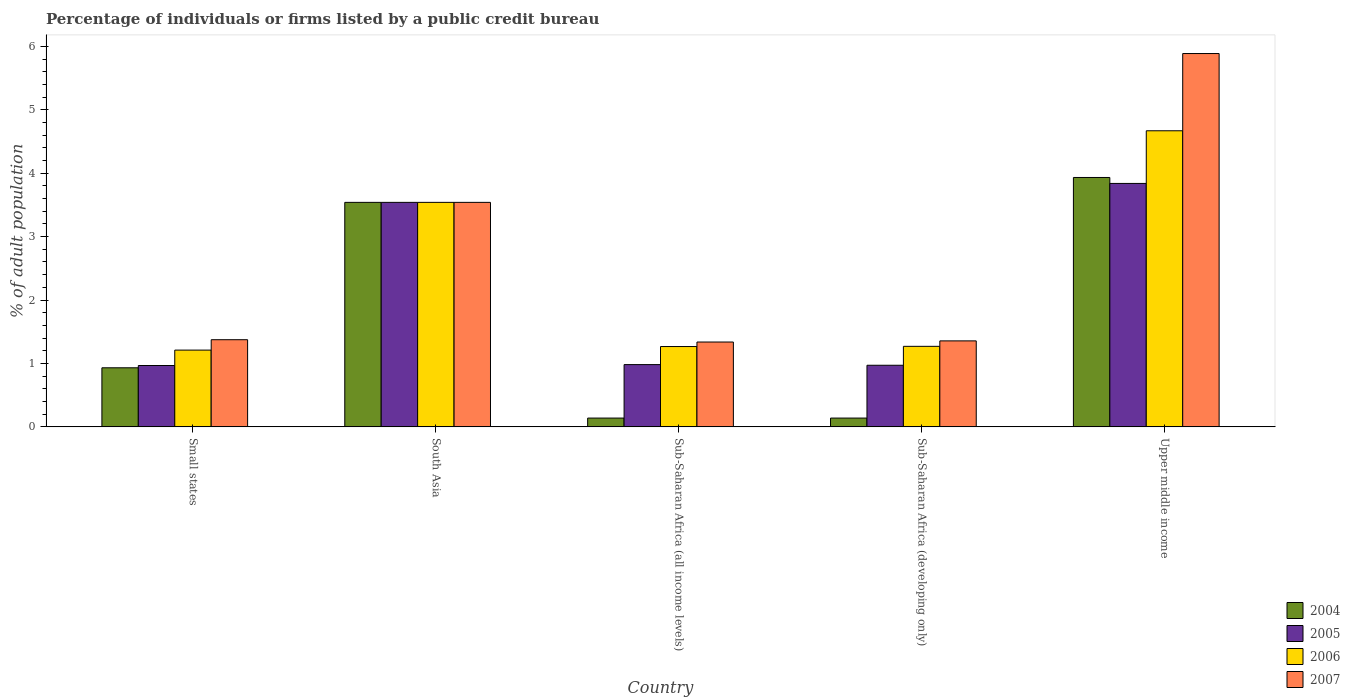How many different coloured bars are there?
Offer a very short reply. 4. How many groups of bars are there?
Provide a short and direct response. 5. Are the number of bars per tick equal to the number of legend labels?
Keep it short and to the point. Yes. Are the number of bars on each tick of the X-axis equal?
Provide a succinct answer. Yes. How many bars are there on the 3rd tick from the left?
Your answer should be compact. 4. How many bars are there on the 4th tick from the right?
Give a very brief answer. 4. In how many cases, is the number of bars for a given country not equal to the number of legend labels?
Your answer should be compact. 0. What is the percentage of population listed by a public credit bureau in 2004 in South Asia?
Offer a very short reply. 3.54. Across all countries, what is the maximum percentage of population listed by a public credit bureau in 2004?
Your answer should be compact. 3.93. Across all countries, what is the minimum percentage of population listed by a public credit bureau in 2004?
Your answer should be compact. 0.14. In which country was the percentage of population listed by a public credit bureau in 2005 maximum?
Give a very brief answer. Upper middle income. In which country was the percentage of population listed by a public credit bureau in 2006 minimum?
Offer a terse response. Small states. What is the total percentage of population listed by a public credit bureau in 2007 in the graph?
Your answer should be very brief. 13.49. What is the difference between the percentage of population listed by a public credit bureau in 2007 in Sub-Saharan Africa (developing only) and that in Upper middle income?
Make the answer very short. -4.53. What is the difference between the percentage of population listed by a public credit bureau in 2007 in Sub-Saharan Africa (all income levels) and the percentage of population listed by a public credit bureau in 2006 in Small states?
Give a very brief answer. 0.13. What is the average percentage of population listed by a public credit bureau in 2005 per country?
Give a very brief answer. 2.06. What is the ratio of the percentage of population listed by a public credit bureau in 2007 in South Asia to that in Upper middle income?
Your response must be concise. 0.6. Is the percentage of population listed by a public credit bureau in 2007 in Sub-Saharan Africa (all income levels) less than that in Sub-Saharan Africa (developing only)?
Your answer should be compact. Yes. Is the difference between the percentage of population listed by a public credit bureau in 2006 in South Asia and Sub-Saharan Africa (developing only) greater than the difference between the percentage of population listed by a public credit bureau in 2004 in South Asia and Sub-Saharan Africa (developing only)?
Your answer should be very brief. No. What is the difference between the highest and the second highest percentage of population listed by a public credit bureau in 2004?
Your answer should be compact. 2.61. What is the difference between the highest and the lowest percentage of population listed by a public credit bureau in 2006?
Offer a very short reply. 3.46. Is the sum of the percentage of population listed by a public credit bureau in 2006 in Sub-Saharan Africa (developing only) and Upper middle income greater than the maximum percentage of population listed by a public credit bureau in 2005 across all countries?
Provide a succinct answer. Yes. What does the 1st bar from the left in Sub-Saharan Africa (all income levels) represents?
Your answer should be very brief. 2004. Is it the case that in every country, the sum of the percentage of population listed by a public credit bureau in 2005 and percentage of population listed by a public credit bureau in 2004 is greater than the percentage of population listed by a public credit bureau in 2006?
Offer a very short reply. No. Are all the bars in the graph horizontal?
Ensure brevity in your answer.  No. Does the graph contain any zero values?
Keep it short and to the point. No. What is the title of the graph?
Give a very brief answer. Percentage of individuals or firms listed by a public credit bureau. What is the label or title of the X-axis?
Give a very brief answer. Country. What is the label or title of the Y-axis?
Make the answer very short. % of adult population. What is the % of adult population of 2004 in Small states?
Make the answer very short. 0.93. What is the % of adult population of 2005 in Small states?
Offer a terse response. 0.97. What is the % of adult population of 2006 in Small states?
Your answer should be very brief. 1.21. What is the % of adult population of 2007 in Small states?
Provide a short and direct response. 1.37. What is the % of adult population in 2004 in South Asia?
Your response must be concise. 3.54. What is the % of adult population in 2005 in South Asia?
Keep it short and to the point. 3.54. What is the % of adult population of 2006 in South Asia?
Give a very brief answer. 3.54. What is the % of adult population of 2007 in South Asia?
Make the answer very short. 3.54. What is the % of adult population of 2004 in Sub-Saharan Africa (all income levels)?
Your answer should be very brief. 0.14. What is the % of adult population of 2005 in Sub-Saharan Africa (all income levels)?
Make the answer very short. 0.98. What is the % of adult population of 2006 in Sub-Saharan Africa (all income levels)?
Provide a succinct answer. 1.27. What is the % of adult population of 2007 in Sub-Saharan Africa (all income levels)?
Make the answer very short. 1.34. What is the % of adult population of 2004 in Sub-Saharan Africa (developing only)?
Provide a succinct answer. 0.14. What is the % of adult population in 2005 in Sub-Saharan Africa (developing only)?
Offer a very short reply. 0.97. What is the % of adult population in 2006 in Sub-Saharan Africa (developing only)?
Offer a terse response. 1.27. What is the % of adult population of 2007 in Sub-Saharan Africa (developing only)?
Ensure brevity in your answer.  1.36. What is the % of adult population of 2004 in Upper middle income?
Make the answer very short. 3.93. What is the % of adult population of 2005 in Upper middle income?
Give a very brief answer. 3.84. What is the % of adult population of 2006 in Upper middle income?
Offer a very short reply. 4.67. What is the % of adult population of 2007 in Upper middle income?
Offer a very short reply. 5.89. Across all countries, what is the maximum % of adult population in 2004?
Ensure brevity in your answer.  3.93. Across all countries, what is the maximum % of adult population of 2005?
Provide a succinct answer. 3.84. Across all countries, what is the maximum % of adult population of 2006?
Offer a terse response. 4.67. Across all countries, what is the maximum % of adult population in 2007?
Provide a short and direct response. 5.89. Across all countries, what is the minimum % of adult population of 2004?
Give a very brief answer. 0.14. Across all countries, what is the minimum % of adult population of 2005?
Your answer should be compact. 0.97. Across all countries, what is the minimum % of adult population in 2006?
Ensure brevity in your answer.  1.21. Across all countries, what is the minimum % of adult population of 2007?
Make the answer very short. 1.34. What is the total % of adult population of 2004 in the graph?
Offer a terse response. 8.68. What is the total % of adult population in 2005 in the graph?
Your answer should be very brief. 10.3. What is the total % of adult population in 2006 in the graph?
Provide a succinct answer. 11.96. What is the total % of adult population in 2007 in the graph?
Your response must be concise. 13.49. What is the difference between the % of adult population of 2004 in Small states and that in South Asia?
Offer a very short reply. -2.61. What is the difference between the % of adult population of 2005 in Small states and that in South Asia?
Your answer should be very brief. -2.57. What is the difference between the % of adult population of 2006 in Small states and that in South Asia?
Your answer should be very brief. -2.33. What is the difference between the % of adult population in 2007 in Small states and that in South Asia?
Provide a short and direct response. -2.17. What is the difference between the % of adult population in 2004 in Small states and that in Sub-Saharan Africa (all income levels)?
Your response must be concise. 0.79. What is the difference between the % of adult population in 2005 in Small states and that in Sub-Saharan Africa (all income levels)?
Keep it short and to the point. -0.01. What is the difference between the % of adult population of 2006 in Small states and that in Sub-Saharan Africa (all income levels)?
Keep it short and to the point. -0.06. What is the difference between the % of adult population of 2007 in Small states and that in Sub-Saharan Africa (all income levels)?
Make the answer very short. 0.04. What is the difference between the % of adult population of 2004 in Small states and that in Sub-Saharan Africa (developing only)?
Keep it short and to the point. 0.79. What is the difference between the % of adult population in 2005 in Small states and that in Sub-Saharan Africa (developing only)?
Your answer should be compact. -0. What is the difference between the % of adult population of 2006 in Small states and that in Sub-Saharan Africa (developing only)?
Make the answer very short. -0.06. What is the difference between the % of adult population of 2007 in Small states and that in Sub-Saharan Africa (developing only)?
Your answer should be very brief. 0.02. What is the difference between the % of adult population of 2004 in Small states and that in Upper middle income?
Your answer should be compact. -3. What is the difference between the % of adult population in 2005 in Small states and that in Upper middle income?
Provide a short and direct response. -2.87. What is the difference between the % of adult population of 2006 in Small states and that in Upper middle income?
Offer a very short reply. -3.46. What is the difference between the % of adult population of 2007 in Small states and that in Upper middle income?
Provide a succinct answer. -4.51. What is the difference between the % of adult population in 2004 in South Asia and that in Sub-Saharan Africa (all income levels)?
Offer a terse response. 3.4. What is the difference between the % of adult population of 2005 in South Asia and that in Sub-Saharan Africa (all income levels)?
Your answer should be very brief. 2.56. What is the difference between the % of adult population of 2006 in South Asia and that in Sub-Saharan Africa (all income levels)?
Offer a very short reply. 2.27. What is the difference between the % of adult population in 2007 in South Asia and that in Sub-Saharan Africa (all income levels)?
Give a very brief answer. 2.2. What is the difference between the % of adult population in 2004 in South Asia and that in Sub-Saharan Africa (developing only)?
Offer a terse response. 3.4. What is the difference between the % of adult population of 2005 in South Asia and that in Sub-Saharan Africa (developing only)?
Offer a very short reply. 2.57. What is the difference between the % of adult population of 2006 in South Asia and that in Sub-Saharan Africa (developing only)?
Offer a very short reply. 2.27. What is the difference between the % of adult population in 2007 in South Asia and that in Sub-Saharan Africa (developing only)?
Give a very brief answer. 2.18. What is the difference between the % of adult population in 2004 in South Asia and that in Upper middle income?
Offer a terse response. -0.39. What is the difference between the % of adult population of 2005 in South Asia and that in Upper middle income?
Keep it short and to the point. -0.3. What is the difference between the % of adult population in 2006 in South Asia and that in Upper middle income?
Your response must be concise. -1.13. What is the difference between the % of adult population of 2007 in South Asia and that in Upper middle income?
Ensure brevity in your answer.  -2.35. What is the difference between the % of adult population of 2004 in Sub-Saharan Africa (all income levels) and that in Sub-Saharan Africa (developing only)?
Offer a terse response. 0. What is the difference between the % of adult population in 2005 in Sub-Saharan Africa (all income levels) and that in Sub-Saharan Africa (developing only)?
Provide a succinct answer. 0.01. What is the difference between the % of adult population of 2006 in Sub-Saharan Africa (all income levels) and that in Sub-Saharan Africa (developing only)?
Your answer should be very brief. -0. What is the difference between the % of adult population of 2007 in Sub-Saharan Africa (all income levels) and that in Sub-Saharan Africa (developing only)?
Provide a short and direct response. -0.02. What is the difference between the % of adult population in 2004 in Sub-Saharan Africa (all income levels) and that in Upper middle income?
Offer a terse response. -3.79. What is the difference between the % of adult population in 2005 in Sub-Saharan Africa (all income levels) and that in Upper middle income?
Give a very brief answer. -2.86. What is the difference between the % of adult population of 2006 in Sub-Saharan Africa (all income levels) and that in Upper middle income?
Provide a succinct answer. -3.4. What is the difference between the % of adult population in 2007 in Sub-Saharan Africa (all income levels) and that in Upper middle income?
Make the answer very short. -4.55. What is the difference between the % of adult population of 2004 in Sub-Saharan Africa (developing only) and that in Upper middle income?
Give a very brief answer. -3.79. What is the difference between the % of adult population of 2005 in Sub-Saharan Africa (developing only) and that in Upper middle income?
Provide a succinct answer. -2.87. What is the difference between the % of adult population in 2006 in Sub-Saharan Africa (developing only) and that in Upper middle income?
Ensure brevity in your answer.  -3.4. What is the difference between the % of adult population of 2007 in Sub-Saharan Africa (developing only) and that in Upper middle income?
Make the answer very short. -4.53. What is the difference between the % of adult population of 2004 in Small states and the % of adult population of 2005 in South Asia?
Keep it short and to the point. -2.61. What is the difference between the % of adult population in 2004 in Small states and the % of adult population in 2006 in South Asia?
Give a very brief answer. -2.61. What is the difference between the % of adult population of 2004 in Small states and the % of adult population of 2007 in South Asia?
Ensure brevity in your answer.  -2.61. What is the difference between the % of adult population of 2005 in Small states and the % of adult population of 2006 in South Asia?
Your answer should be very brief. -2.57. What is the difference between the % of adult population in 2005 in Small states and the % of adult population in 2007 in South Asia?
Provide a short and direct response. -2.57. What is the difference between the % of adult population in 2006 in Small states and the % of adult population in 2007 in South Asia?
Offer a very short reply. -2.33. What is the difference between the % of adult population in 2004 in Small states and the % of adult population in 2005 in Sub-Saharan Africa (all income levels)?
Offer a terse response. -0.05. What is the difference between the % of adult population of 2004 in Small states and the % of adult population of 2006 in Sub-Saharan Africa (all income levels)?
Offer a terse response. -0.34. What is the difference between the % of adult population of 2004 in Small states and the % of adult population of 2007 in Sub-Saharan Africa (all income levels)?
Your response must be concise. -0.41. What is the difference between the % of adult population of 2005 in Small states and the % of adult population of 2006 in Sub-Saharan Africa (all income levels)?
Offer a very short reply. -0.3. What is the difference between the % of adult population of 2005 in Small states and the % of adult population of 2007 in Sub-Saharan Africa (all income levels)?
Offer a very short reply. -0.37. What is the difference between the % of adult population of 2006 in Small states and the % of adult population of 2007 in Sub-Saharan Africa (all income levels)?
Offer a terse response. -0.13. What is the difference between the % of adult population in 2004 in Small states and the % of adult population in 2005 in Sub-Saharan Africa (developing only)?
Offer a very short reply. -0.04. What is the difference between the % of adult population in 2004 in Small states and the % of adult population in 2006 in Sub-Saharan Africa (developing only)?
Make the answer very short. -0.34. What is the difference between the % of adult population in 2004 in Small states and the % of adult population in 2007 in Sub-Saharan Africa (developing only)?
Offer a very short reply. -0.42. What is the difference between the % of adult population in 2005 in Small states and the % of adult population in 2006 in Sub-Saharan Africa (developing only)?
Your answer should be very brief. -0.3. What is the difference between the % of adult population of 2005 in Small states and the % of adult population of 2007 in Sub-Saharan Africa (developing only)?
Offer a terse response. -0.39. What is the difference between the % of adult population of 2006 in Small states and the % of adult population of 2007 in Sub-Saharan Africa (developing only)?
Offer a terse response. -0.15. What is the difference between the % of adult population of 2004 in Small states and the % of adult population of 2005 in Upper middle income?
Give a very brief answer. -2.91. What is the difference between the % of adult population of 2004 in Small states and the % of adult population of 2006 in Upper middle income?
Provide a succinct answer. -3.74. What is the difference between the % of adult population of 2004 in Small states and the % of adult population of 2007 in Upper middle income?
Your answer should be very brief. -4.96. What is the difference between the % of adult population in 2005 in Small states and the % of adult population in 2006 in Upper middle income?
Make the answer very short. -3.7. What is the difference between the % of adult population of 2005 in Small states and the % of adult population of 2007 in Upper middle income?
Offer a terse response. -4.92. What is the difference between the % of adult population in 2006 in Small states and the % of adult population in 2007 in Upper middle income?
Make the answer very short. -4.68. What is the difference between the % of adult population of 2004 in South Asia and the % of adult population of 2005 in Sub-Saharan Africa (all income levels)?
Make the answer very short. 2.56. What is the difference between the % of adult population in 2004 in South Asia and the % of adult population in 2006 in Sub-Saharan Africa (all income levels)?
Provide a short and direct response. 2.27. What is the difference between the % of adult population of 2004 in South Asia and the % of adult population of 2007 in Sub-Saharan Africa (all income levels)?
Give a very brief answer. 2.2. What is the difference between the % of adult population of 2005 in South Asia and the % of adult population of 2006 in Sub-Saharan Africa (all income levels)?
Provide a succinct answer. 2.27. What is the difference between the % of adult population of 2005 in South Asia and the % of adult population of 2007 in Sub-Saharan Africa (all income levels)?
Ensure brevity in your answer.  2.2. What is the difference between the % of adult population in 2006 in South Asia and the % of adult population in 2007 in Sub-Saharan Africa (all income levels)?
Provide a succinct answer. 2.2. What is the difference between the % of adult population of 2004 in South Asia and the % of adult population of 2005 in Sub-Saharan Africa (developing only)?
Your response must be concise. 2.57. What is the difference between the % of adult population of 2004 in South Asia and the % of adult population of 2006 in Sub-Saharan Africa (developing only)?
Give a very brief answer. 2.27. What is the difference between the % of adult population in 2004 in South Asia and the % of adult population in 2007 in Sub-Saharan Africa (developing only)?
Keep it short and to the point. 2.18. What is the difference between the % of adult population in 2005 in South Asia and the % of adult population in 2006 in Sub-Saharan Africa (developing only)?
Offer a very short reply. 2.27. What is the difference between the % of adult population in 2005 in South Asia and the % of adult population in 2007 in Sub-Saharan Africa (developing only)?
Ensure brevity in your answer.  2.18. What is the difference between the % of adult population of 2006 in South Asia and the % of adult population of 2007 in Sub-Saharan Africa (developing only)?
Your answer should be compact. 2.18. What is the difference between the % of adult population in 2004 in South Asia and the % of adult population in 2005 in Upper middle income?
Provide a short and direct response. -0.3. What is the difference between the % of adult population in 2004 in South Asia and the % of adult population in 2006 in Upper middle income?
Keep it short and to the point. -1.13. What is the difference between the % of adult population of 2004 in South Asia and the % of adult population of 2007 in Upper middle income?
Provide a short and direct response. -2.35. What is the difference between the % of adult population in 2005 in South Asia and the % of adult population in 2006 in Upper middle income?
Your answer should be very brief. -1.13. What is the difference between the % of adult population in 2005 in South Asia and the % of adult population in 2007 in Upper middle income?
Your answer should be very brief. -2.35. What is the difference between the % of adult population of 2006 in South Asia and the % of adult population of 2007 in Upper middle income?
Provide a short and direct response. -2.35. What is the difference between the % of adult population in 2004 in Sub-Saharan Africa (all income levels) and the % of adult population in 2005 in Sub-Saharan Africa (developing only)?
Make the answer very short. -0.83. What is the difference between the % of adult population in 2004 in Sub-Saharan Africa (all income levels) and the % of adult population in 2006 in Sub-Saharan Africa (developing only)?
Ensure brevity in your answer.  -1.13. What is the difference between the % of adult population of 2004 in Sub-Saharan Africa (all income levels) and the % of adult population of 2007 in Sub-Saharan Africa (developing only)?
Make the answer very short. -1.22. What is the difference between the % of adult population of 2005 in Sub-Saharan Africa (all income levels) and the % of adult population of 2006 in Sub-Saharan Africa (developing only)?
Offer a very short reply. -0.29. What is the difference between the % of adult population of 2005 in Sub-Saharan Africa (all income levels) and the % of adult population of 2007 in Sub-Saharan Africa (developing only)?
Your answer should be very brief. -0.37. What is the difference between the % of adult population in 2006 in Sub-Saharan Africa (all income levels) and the % of adult population in 2007 in Sub-Saharan Africa (developing only)?
Provide a short and direct response. -0.09. What is the difference between the % of adult population of 2004 in Sub-Saharan Africa (all income levels) and the % of adult population of 2005 in Upper middle income?
Offer a terse response. -3.7. What is the difference between the % of adult population in 2004 in Sub-Saharan Africa (all income levels) and the % of adult population in 2006 in Upper middle income?
Provide a short and direct response. -4.53. What is the difference between the % of adult population in 2004 in Sub-Saharan Africa (all income levels) and the % of adult population in 2007 in Upper middle income?
Your answer should be compact. -5.75. What is the difference between the % of adult population of 2005 in Sub-Saharan Africa (all income levels) and the % of adult population of 2006 in Upper middle income?
Keep it short and to the point. -3.69. What is the difference between the % of adult population of 2005 in Sub-Saharan Africa (all income levels) and the % of adult population of 2007 in Upper middle income?
Offer a very short reply. -4.9. What is the difference between the % of adult population of 2006 in Sub-Saharan Africa (all income levels) and the % of adult population of 2007 in Upper middle income?
Your answer should be compact. -4.62. What is the difference between the % of adult population of 2004 in Sub-Saharan Africa (developing only) and the % of adult population of 2005 in Upper middle income?
Offer a very short reply. -3.7. What is the difference between the % of adult population of 2004 in Sub-Saharan Africa (developing only) and the % of adult population of 2006 in Upper middle income?
Ensure brevity in your answer.  -4.53. What is the difference between the % of adult population of 2004 in Sub-Saharan Africa (developing only) and the % of adult population of 2007 in Upper middle income?
Give a very brief answer. -5.75. What is the difference between the % of adult population of 2005 in Sub-Saharan Africa (developing only) and the % of adult population of 2006 in Upper middle income?
Give a very brief answer. -3.7. What is the difference between the % of adult population of 2005 in Sub-Saharan Africa (developing only) and the % of adult population of 2007 in Upper middle income?
Offer a terse response. -4.92. What is the difference between the % of adult population of 2006 in Sub-Saharan Africa (developing only) and the % of adult population of 2007 in Upper middle income?
Your answer should be very brief. -4.62. What is the average % of adult population in 2004 per country?
Offer a very short reply. 1.74. What is the average % of adult population of 2005 per country?
Your answer should be very brief. 2.06. What is the average % of adult population of 2006 per country?
Your answer should be compact. 2.39. What is the average % of adult population in 2007 per country?
Provide a succinct answer. 2.7. What is the difference between the % of adult population of 2004 and % of adult population of 2005 in Small states?
Keep it short and to the point. -0.04. What is the difference between the % of adult population in 2004 and % of adult population in 2006 in Small states?
Offer a terse response. -0.28. What is the difference between the % of adult population of 2004 and % of adult population of 2007 in Small states?
Your answer should be compact. -0.44. What is the difference between the % of adult population in 2005 and % of adult population in 2006 in Small states?
Ensure brevity in your answer.  -0.24. What is the difference between the % of adult population in 2005 and % of adult population in 2007 in Small states?
Ensure brevity in your answer.  -0.41. What is the difference between the % of adult population in 2006 and % of adult population in 2007 in Small states?
Offer a very short reply. -0.16. What is the difference between the % of adult population in 2004 and % of adult population in 2005 in South Asia?
Provide a succinct answer. 0. What is the difference between the % of adult population in 2004 and % of adult population in 2007 in South Asia?
Ensure brevity in your answer.  0. What is the difference between the % of adult population of 2005 and % of adult population of 2006 in South Asia?
Give a very brief answer. 0. What is the difference between the % of adult population in 2005 and % of adult population in 2007 in South Asia?
Give a very brief answer. 0. What is the difference between the % of adult population in 2006 and % of adult population in 2007 in South Asia?
Make the answer very short. 0. What is the difference between the % of adult population of 2004 and % of adult population of 2005 in Sub-Saharan Africa (all income levels)?
Make the answer very short. -0.84. What is the difference between the % of adult population in 2004 and % of adult population in 2006 in Sub-Saharan Africa (all income levels)?
Your answer should be very brief. -1.13. What is the difference between the % of adult population in 2004 and % of adult population in 2007 in Sub-Saharan Africa (all income levels)?
Give a very brief answer. -1.2. What is the difference between the % of adult population of 2005 and % of adult population of 2006 in Sub-Saharan Africa (all income levels)?
Your answer should be compact. -0.28. What is the difference between the % of adult population of 2005 and % of adult population of 2007 in Sub-Saharan Africa (all income levels)?
Give a very brief answer. -0.36. What is the difference between the % of adult population of 2006 and % of adult population of 2007 in Sub-Saharan Africa (all income levels)?
Offer a terse response. -0.07. What is the difference between the % of adult population of 2004 and % of adult population of 2005 in Sub-Saharan Africa (developing only)?
Keep it short and to the point. -0.83. What is the difference between the % of adult population in 2004 and % of adult population in 2006 in Sub-Saharan Africa (developing only)?
Ensure brevity in your answer.  -1.13. What is the difference between the % of adult population in 2004 and % of adult population in 2007 in Sub-Saharan Africa (developing only)?
Ensure brevity in your answer.  -1.22. What is the difference between the % of adult population of 2005 and % of adult population of 2006 in Sub-Saharan Africa (developing only)?
Ensure brevity in your answer.  -0.3. What is the difference between the % of adult population of 2005 and % of adult population of 2007 in Sub-Saharan Africa (developing only)?
Your response must be concise. -0.38. What is the difference between the % of adult population of 2006 and % of adult population of 2007 in Sub-Saharan Africa (developing only)?
Offer a terse response. -0.09. What is the difference between the % of adult population in 2004 and % of adult population in 2005 in Upper middle income?
Ensure brevity in your answer.  0.09. What is the difference between the % of adult population in 2004 and % of adult population in 2006 in Upper middle income?
Offer a terse response. -0.74. What is the difference between the % of adult population of 2004 and % of adult population of 2007 in Upper middle income?
Provide a short and direct response. -1.95. What is the difference between the % of adult population of 2005 and % of adult population of 2006 in Upper middle income?
Give a very brief answer. -0.83. What is the difference between the % of adult population in 2005 and % of adult population in 2007 in Upper middle income?
Your answer should be very brief. -2.05. What is the difference between the % of adult population in 2006 and % of adult population in 2007 in Upper middle income?
Your answer should be compact. -1.22. What is the ratio of the % of adult population of 2004 in Small states to that in South Asia?
Provide a short and direct response. 0.26. What is the ratio of the % of adult population in 2005 in Small states to that in South Asia?
Your answer should be very brief. 0.27. What is the ratio of the % of adult population in 2006 in Small states to that in South Asia?
Offer a very short reply. 0.34. What is the ratio of the % of adult population in 2007 in Small states to that in South Asia?
Give a very brief answer. 0.39. What is the ratio of the % of adult population of 2004 in Small states to that in Sub-Saharan Africa (all income levels)?
Your answer should be compact. 6.71. What is the ratio of the % of adult population in 2005 in Small states to that in Sub-Saharan Africa (all income levels)?
Provide a succinct answer. 0.99. What is the ratio of the % of adult population of 2006 in Small states to that in Sub-Saharan Africa (all income levels)?
Make the answer very short. 0.96. What is the ratio of the % of adult population in 2007 in Small states to that in Sub-Saharan Africa (all income levels)?
Provide a short and direct response. 1.03. What is the ratio of the % of adult population of 2004 in Small states to that in Sub-Saharan Africa (developing only)?
Your response must be concise. 6.71. What is the ratio of the % of adult population of 2006 in Small states to that in Sub-Saharan Africa (developing only)?
Keep it short and to the point. 0.95. What is the ratio of the % of adult population in 2007 in Small states to that in Sub-Saharan Africa (developing only)?
Keep it short and to the point. 1.01. What is the ratio of the % of adult population of 2004 in Small states to that in Upper middle income?
Offer a terse response. 0.24. What is the ratio of the % of adult population in 2005 in Small states to that in Upper middle income?
Your response must be concise. 0.25. What is the ratio of the % of adult population of 2006 in Small states to that in Upper middle income?
Your answer should be compact. 0.26. What is the ratio of the % of adult population of 2007 in Small states to that in Upper middle income?
Ensure brevity in your answer.  0.23. What is the ratio of the % of adult population of 2004 in South Asia to that in Sub-Saharan Africa (all income levels)?
Offer a terse response. 25.49. What is the ratio of the % of adult population in 2005 in South Asia to that in Sub-Saharan Africa (all income levels)?
Provide a succinct answer. 3.61. What is the ratio of the % of adult population in 2006 in South Asia to that in Sub-Saharan Africa (all income levels)?
Offer a very short reply. 2.79. What is the ratio of the % of adult population of 2007 in South Asia to that in Sub-Saharan Africa (all income levels)?
Ensure brevity in your answer.  2.65. What is the ratio of the % of adult population in 2004 in South Asia to that in Sub-Saharan Africa (developing only)?
Give a very brief answer. 25.49. What is the ratio of the % of adult population of 2005 in South Asia to that in Sub-Saharan Africa (developing only)?
Provide a succinct answer. 3.64. What is the ratio of the % of adult population in 2006 in South Asia to that in Sub-Saharan Africa (developing only)?
Provide a succinct answer. 2.79. What is the ratio of the % of adult population in 2007 in South Asia to that in Sub-Saharan Africa (developing only)?
Give a very brief answer. 2.61. What is the ratio of the % of adult population in 2004 in South Asia to that in Upper middle income?
Your response must be concise. 0.9. What is the ratio of the % of adult population of 2005 in South Asia to that in Upper middle income?
Keep it short and to the point. 0.92. What is the ratio of the % of adult population in 2006 in South Asia to that in Upper middle income?
Your response must be concise. 0.76. What is the ratio of the % of adult population in 2007 in South Asia to that in Upper middle income?
Offer a terse response. 0.6. What is the ratio of the % of adult population in 2004 in Sub-Saharan Africa (all income levels) to that in Sub-Saharan Africa (developing only)?
Offer a very short reply. 1. What is the ratio of the % of adult population in 2005 in Sub-Saharan Africa (all income levels) to that in Sub-Saharan Africa (developing only)?
Your answer should be compact. 1.01. What is the ratio of the % of adult population in 2006 in Sub-Saharan Africa (all income levels) to that in Sub-Saharan Africa (developing only)?
Offer a terse response. 1. What is the ratio of the % of adult population of 2007 in Sub-Saharan Africa (all income levels) to that in Sub-Saharan Africa (developing only)?
Keep it short and to the point. 0.99. What is the ratio of the % of adult population of 2004 in Sub-Saharan Africa (all income levels) to that in Upper middle income?
Your answer should be compact. 0.04. What is the ratio of the % of adult population of 2005 in Sub-Saharan Africa (all income levels) to that in Upper middle income?
Offer a very short reply. 0.26. What is the ratio of the % of adult population of 2006 in Sub-Saharan Africa (all income levels) to that in Upper middle income?
Your answer should be very brief. 0.27. What is the ratio of the % of adult population in 2007 in Sub-Saharan Africa (all income levels) to that in Upper middle income?
Offer a terse response. 0.23. What is the ratio of the % of adult population of 2004 in Sub-Saharan Africa (developing only) to that in Upper middle income?
Ensure brevity in your answer.  0.04. What is the ratio of the % of adult population of 2005 in Sub-Saharan Africa (developing only) to that in Upper middle income?
Provide a short and direct response. 0.25. What is the ratio of the % of adult population in 2006 in Sub-Saharan Africa (developing only) to that in Upper middle income?
Provide a short and direct response. 0.27. What is the ratio of the % of adult population in 2007 in Sub-Saharan Africa (developing only) to that in Upper middle income?
Give a very brief answer. 0.23. What is the difference between the highest and the second highest % of adult population in 2004?
Offer a very short reply. 0.39. What is the difference between the highest and the second highest % of adult population in 2005?
Ensure brevity in your answer.  0.3. What is the difference between the highest and the second highest % of adult population of 2006?
Offer a terse response. 1.13. What is the difference between the highest and the second highest % of adult population in 2007?
Make the answer very short. 2.35. What is the difference between the highest and the lowest % of adult population of 2004?
Your answer should be very brief. 3.79. What is the difference between the highest and the lowest % of adult population of 2005?
Your answer should be compact. 2.87. What is the difference between the highest and the lowest % of adult population in 2006?
Offer a very short reply. 3.46. What is the difference between the highest and the lowest % of adult population of 2007?
Your answer should be very brief. 4.55. 